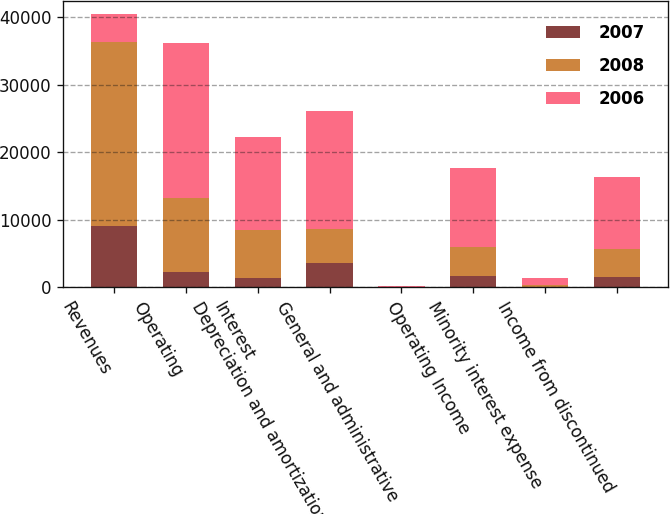Convert chart. <chart><loc_0><loc_0><loc_500><loc_500><stacked_bar_chart><ecel><fcel>Revenues<fcel>Operating<fcel>Interest<fcel>Depreciation and amortization<fcel>General and administrative<fcel>Operating Income<fcel>Minority interest expense<fcel>Income from discontinued<nl><fcel>2007<fcel>9012<fcel>2242<fcel>1440<fcel>3673<fcel>2<fcel>1655<fcel>82<fcel>1573<nl><fcel>2008<fcel>27343<fcel>10997<fcel>7030<fcel>4941<fcel>38<fcel>4337<fcel>269<fcel>4068<nl><fcel>2006<fcel>4068<fcel>22898<fcel>13848<fcel>17422<fcel>105<fcel>11696<fcel>1042<fcel>10654<nl></chart> 